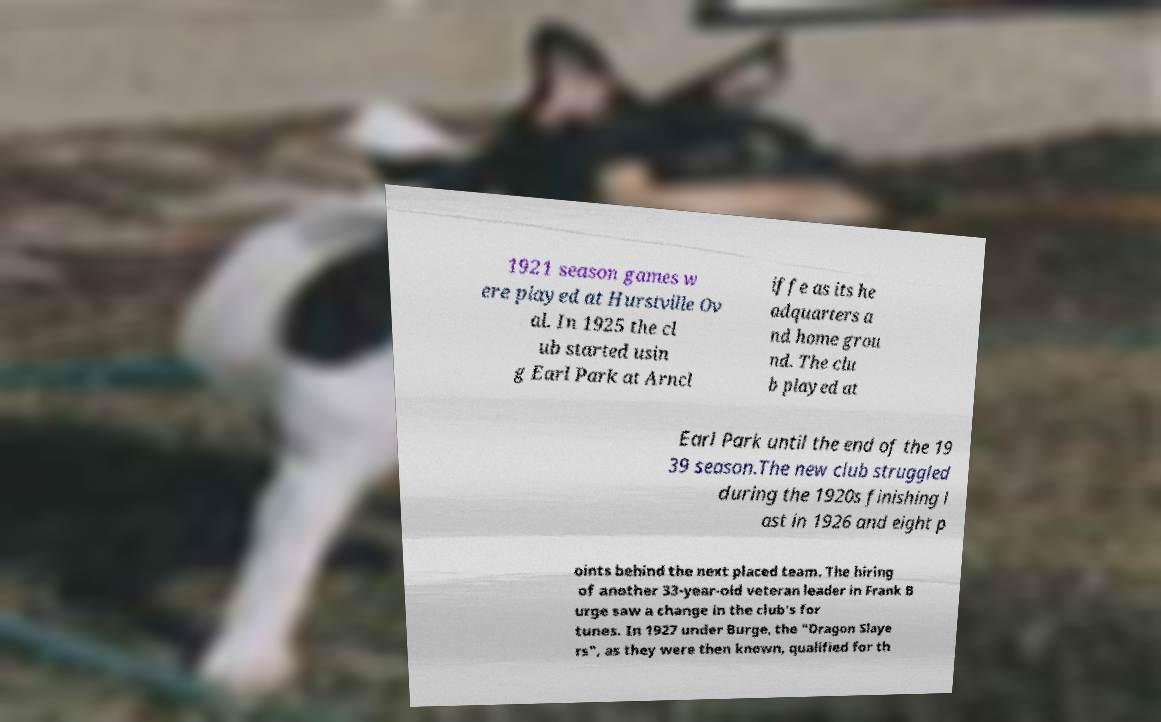Please read and relay the text visible in this image. What does it say? 1921 season games w ere played at Hurstville Ov al. In 1925 the cl ub started usin g Earl Park at Arncl iffe as its he adquarters a nd home grou nd. The clu b played at Earl Park until the end of the 19 39 season.The new club struggled during the 1920s finishing l ast in 1926 and eight p oints behind the next placed team. The hiring of another 33-year-old veteran leader in Frank B urge saw a change in the club's for tunes. In 1927 under Burge, the "Dragon Slaye rs", as they were then known, qualified for th 